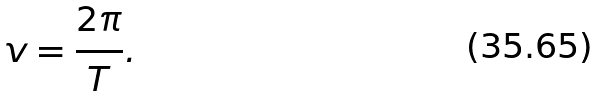Convert formula to latex. <formula><loc_0><loc_0><loc_500><loc_500>v = \frac { 2 \pi } { T } .</formula> 